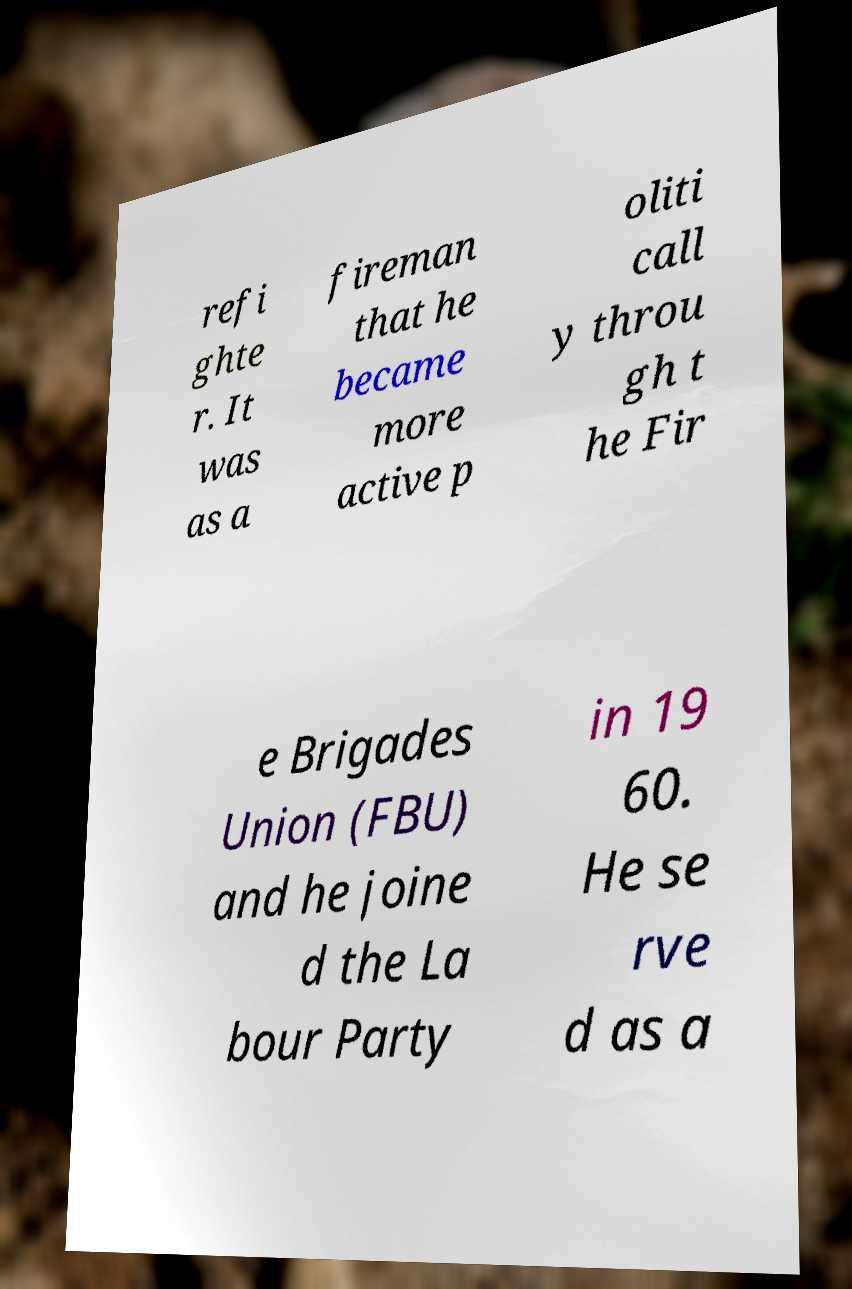What messages or text are displayed in this image? I need them in a readable, typed format. refi ghte r. It was as a fireman that he became more active p oliti call y throu gh t he Fir e Brigades Union (FBU) and he joine d the La bour Party in 19 60. He se rve d as a 